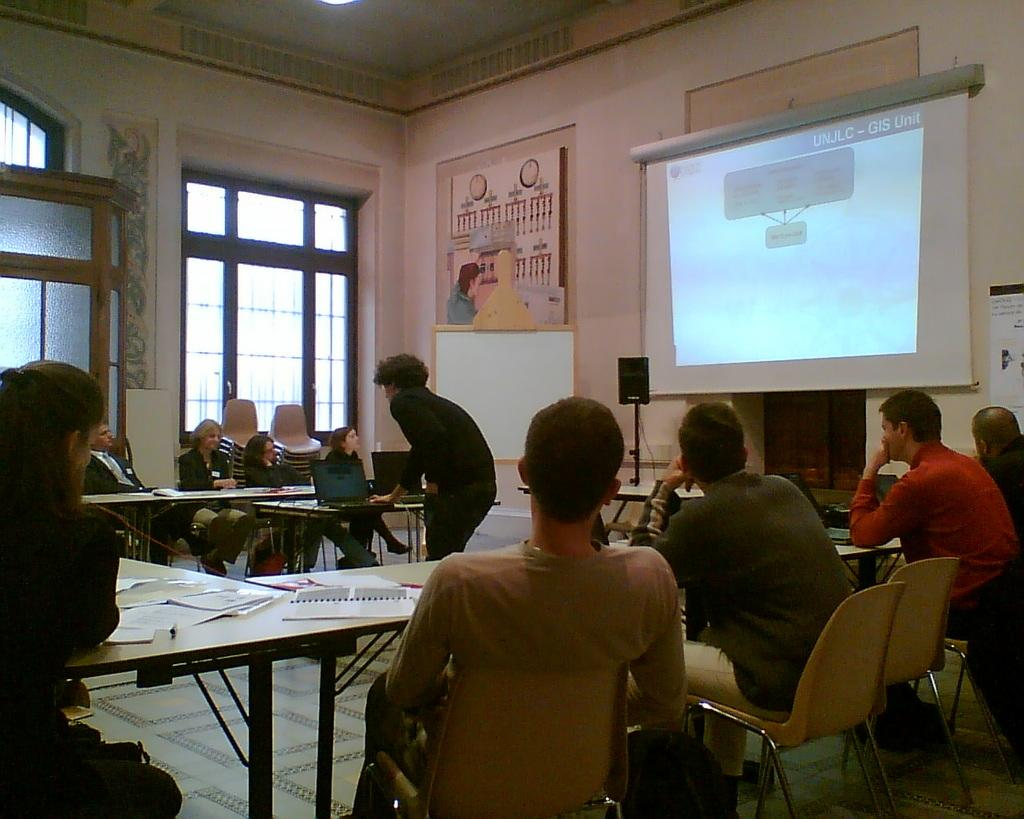What are the people in the image doing? The people in the image are sitting on chairs. Can you describe the person in the middle of the image? There is a person standing in the middle of the image. What is on the table in the image? There is a laptop on the table. What might the people be using the laptop for? It is not clear from the image what the people might be using the laptop for. What type of cloth is being used to grow potatoes in the image? There is no cloth or potatoes present in the image. 